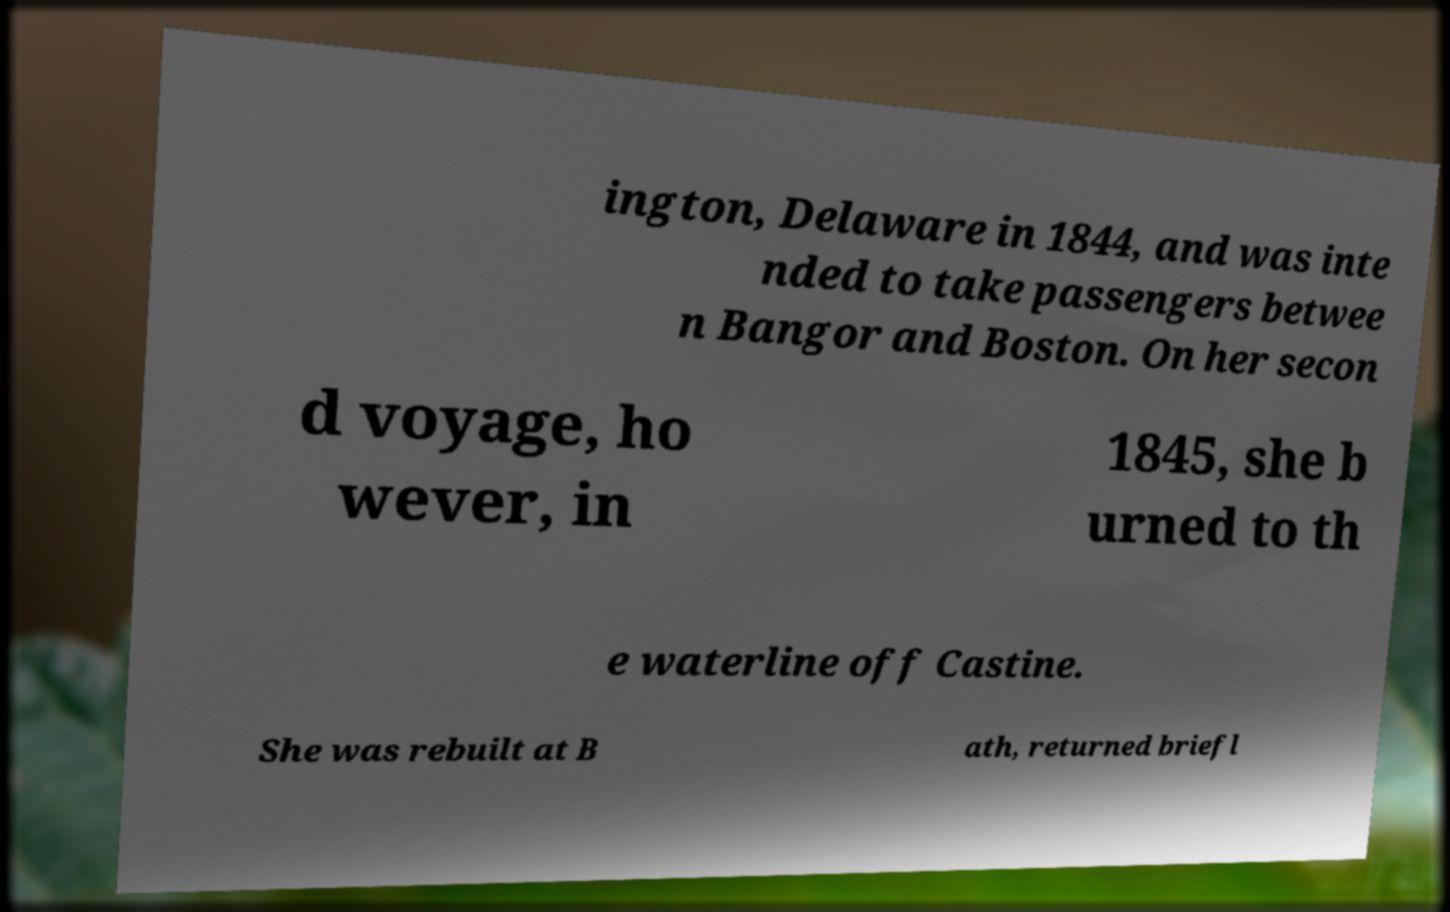There's text embedded in this image that I need extracted. Can you transcribe it verbatim? ington, Delaware in 1844, and was inte nded to take passengers betwee n Bangor and Boston. On her secon d voyage, ho wever, in 1845, she b urned to th e waterline off Castine. She was rebuilt at B ath, returned briefl 